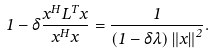<formula> <loc_0><loc_0><loc_500><loc_500>1 - \delta \frac { x ^ { H } L ^ { T } x } { x ^ { H } x } = \frac { 1 } { \left ( 1 - \delta \lambda \right ) \left \| x \right \| ^ { 2 } } .</formula> 